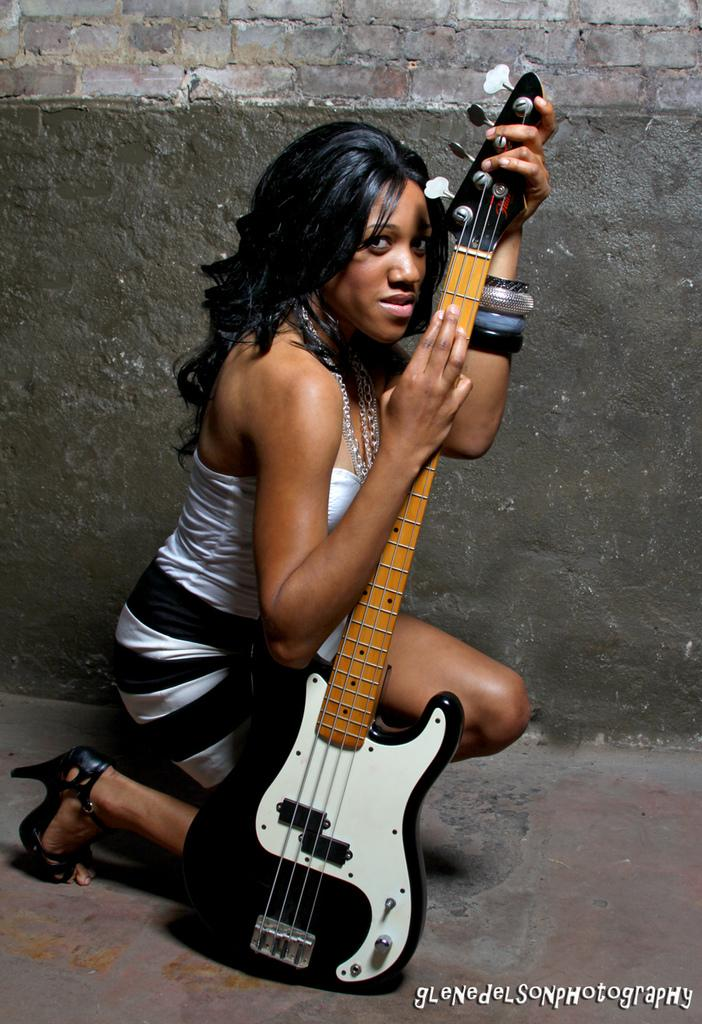Who is in the image? There is a woman in the image. What is the woman doing in the image? The woman is sitting on the floor and holding a guitar. What is the woman wearing in the image? The woman is wearing a white dress and black slippers. What can be seen in the background of the image? There is a wall in the background of the image. What type of drum can be seen in the woman's hand in the image? There is no drum present in the image; the woman is holding a guitar. Is the woman using a quill to write on the wall in the image? There is no quill or writing on the wall in the image. 